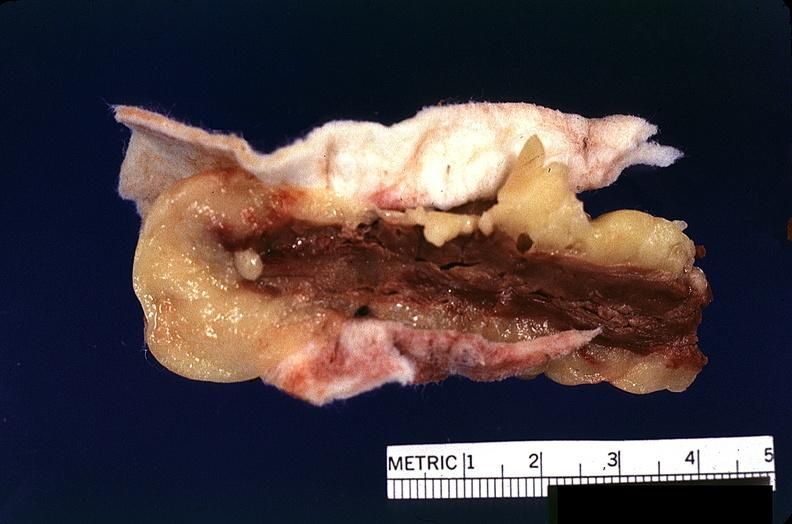where is this?
Answer the question using a single word or phrase. Heart 